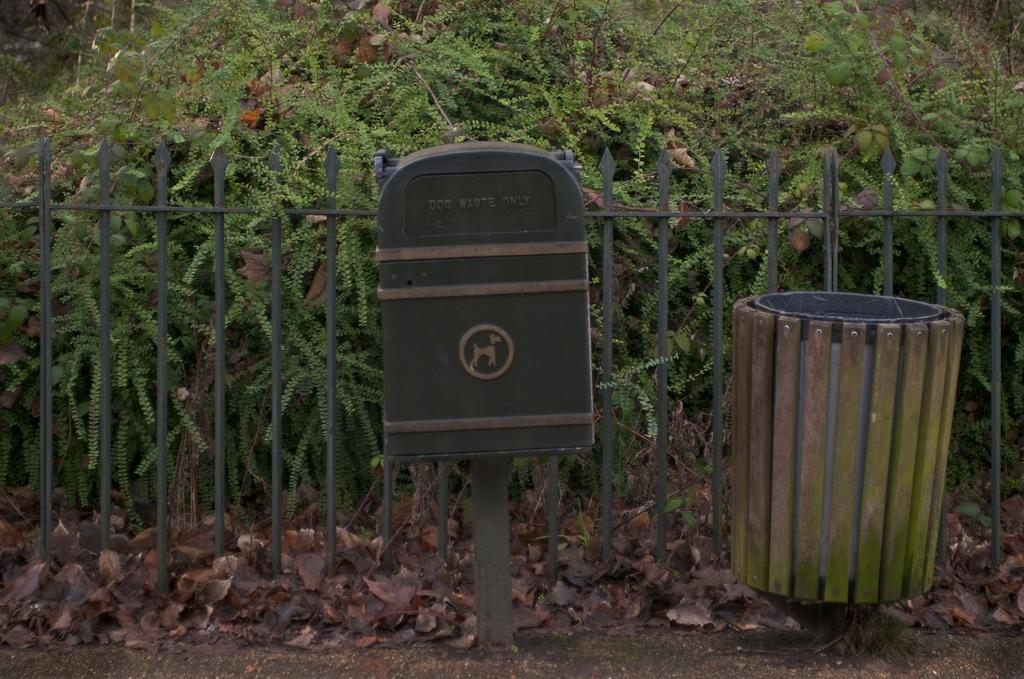<image>
Offer a succinct explanation of the picture presented. A Dog waste only disposal can next to a regular trash bin along a fence. 